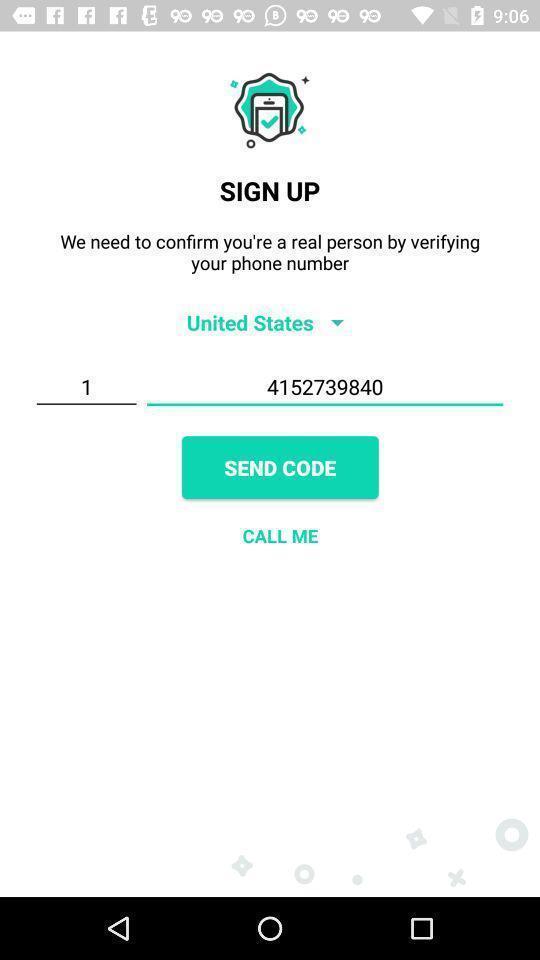Describe the visual elements of this screenshot. Sign up verification page. 